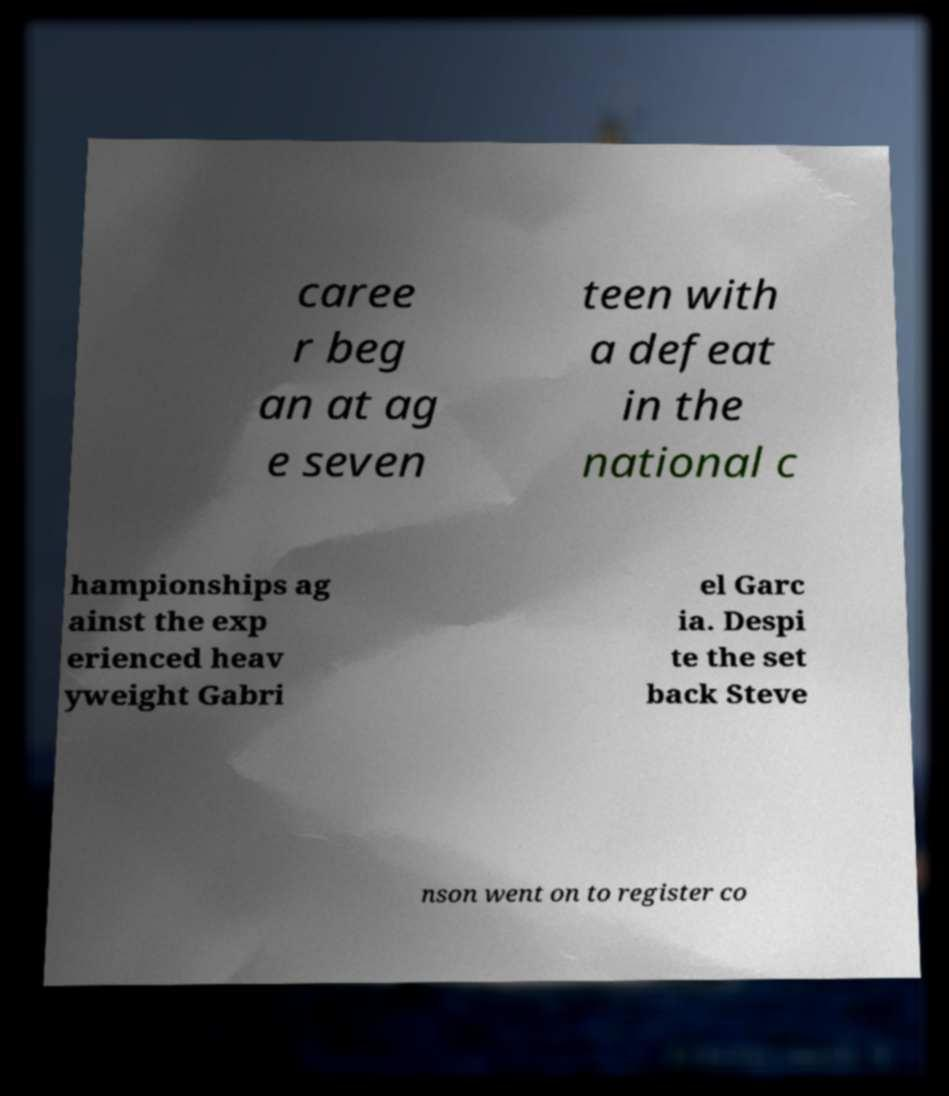Please identify and transcribe the text found in this image. caree r beg an at ag e seven teen with a defeat in the national c hampionships ag ainst the exp erienced heav yweight Gabri el Garc ia. Despi te the set back Steve nson went on to register co 